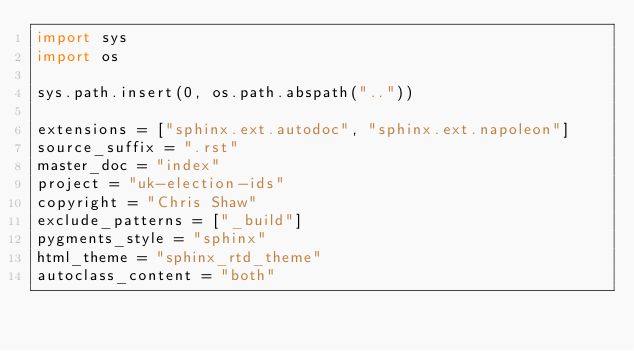Convert code to text. <code><loc_0><loc_0><loc_500><loc_500><_Python_>import sys
import os

sys.path.insert(0, os.path.abspath(".."))

extensions = ["sphinx.ext.autodoc", "sphinx.ext.napoleon"]
source_suffix = ".rst"
master_doc = "index"
project = "uk-election-ids"
copyright = "Chris Shaw"
exclude_patterns = ["_build"]
pygments_style = "sphinx"
html_theme = "sphinx_rtd_theme"
autoclass_content = "both"
</code> 